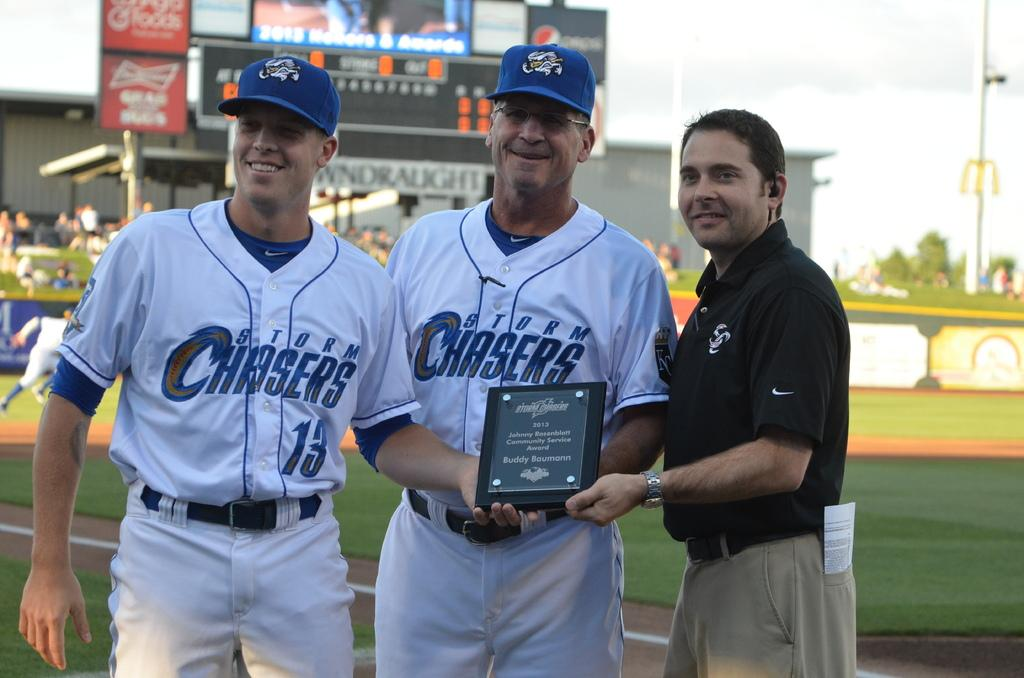Provide a one-sentence caption for the provided image. Some players for the Storm Chasers pose with a plaque in 2013. 